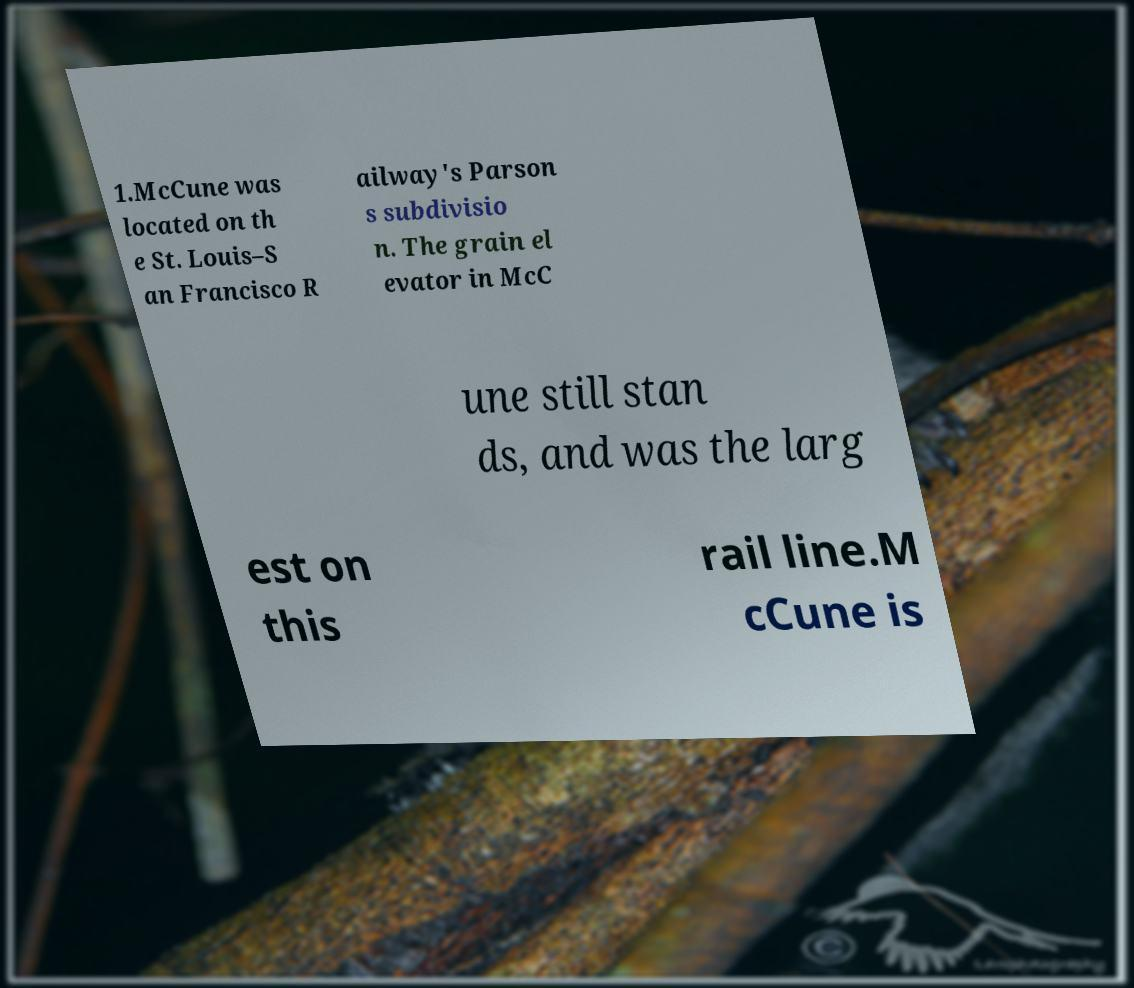Please identify and transcribe the text found in this image. 1.McCune was located on th e St. Louis–S an Francisco R ailway's Parson s subdivisio n. The grain el evator in McC une still stan ds, and was the larg est on this rail line.M cCune is 